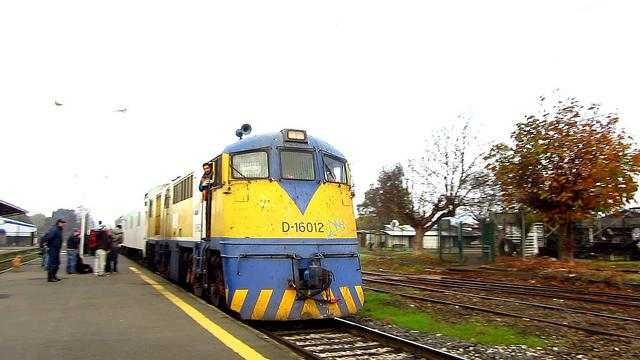What are the people waiting to do? board train 